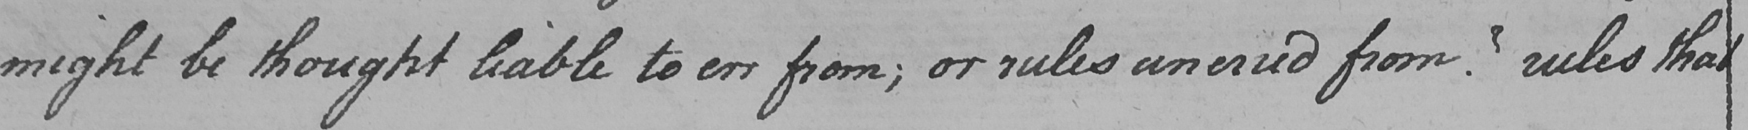Please transcribe the handwritten text in this image. might be thought liable to err from ; or rules unerred from ?  rules that 